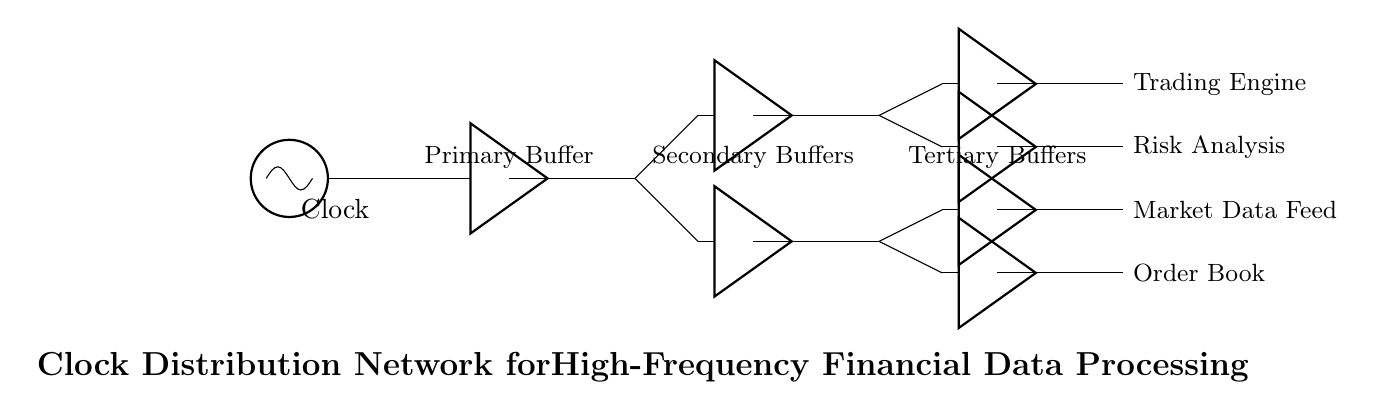What is the main component of this circuit? The main component is the clock source, which is depicted at the left side of the diagram. It provides the timing signal for the entire circuit, essential for synchronization.
Answer: Clock How many secondary clock buffers are present in the circuit? The diagram shows two secondary buffers connected to the primary buffer, indicating their role in distributing the clock signal. Counting the buffers gives us a total of two secondary clock buffers.
Answer: Two What outputs connect to the tertiary clock buffers? The tertiary buffers are connected to the secondary buffers and distribute the clock signal to four specific outputs labeled as Trading Engine, Risk Analysis, Market Data Feed, and Order Book, ensuring each component receives the clock signal.
Answer: Trading Engine, Risk Analysis, Market Data Feed, Order Book What function do the buffers serve in this circuit? The buffers serve to amplify the clock signal and distribute it to different components without loading down the primary clock signal, which is vital for maintaining signal integrity across the circuit.
Answer: Amplify and distribute How many total clock buffers are depicted in the diagram? The circuit shows one primary buffer, two secondary buffers, and four tertiary buffers, so you add these up—one plus two plus four gives a total of seven clock buffers throughout the circuit.
Answer: Seven 